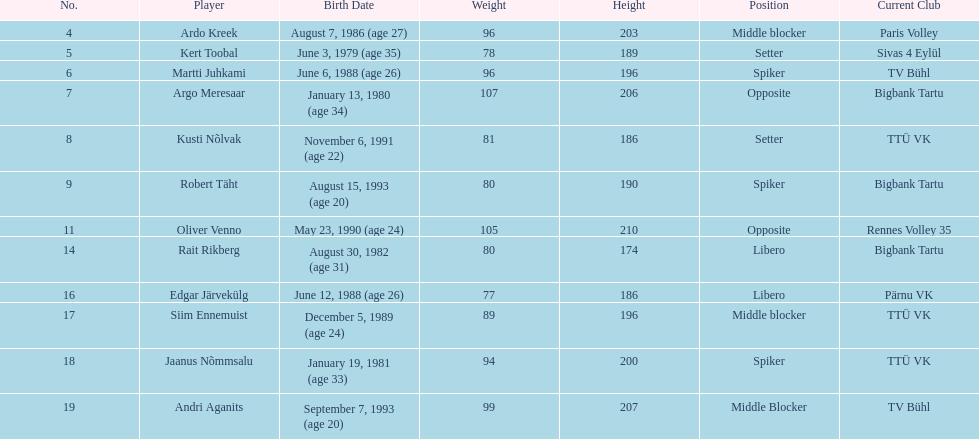What are the team members' heights in centimeters? 203, 189, 196, 206, 186, 190, 210, 174, 186, 196, 200, 207. What is the maximum height of a player on the team? 210. Who is the player with a height of 210 cm? Oliver Venno. 